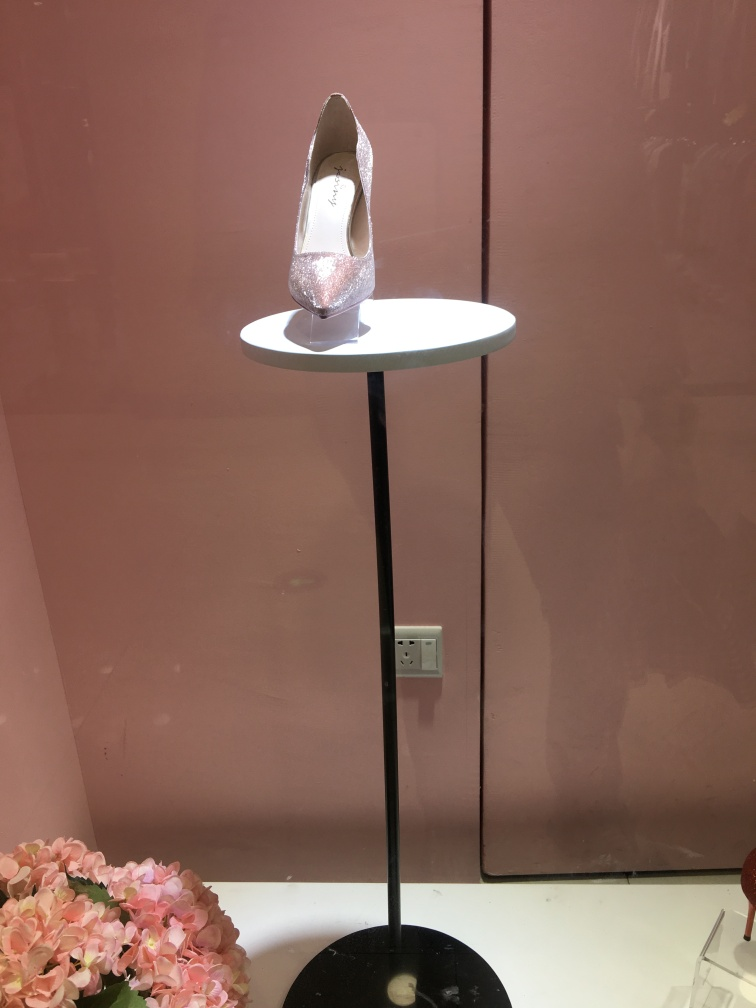What is the overall clarity of the photo? The photo has good clarity in terms of focus and sharpness, capturing the details of the glittering shoe prominently displayed on the stand. The lighting is well-balanced, highlighting the shoe's texture without creating harsh reflections. However, the surrounding setting has room for improvement, as the background features a few distractions such as an electrical outlet and reflections on the left side. 